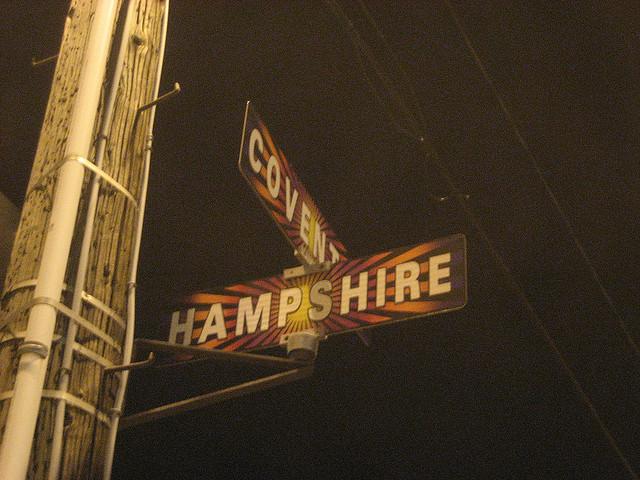Is it nighttime?
Short answer required. Yes. How many signs are there?
Write a very short answer. 2. What does the bottom sign say?
Quick response, please. Hampshire. 